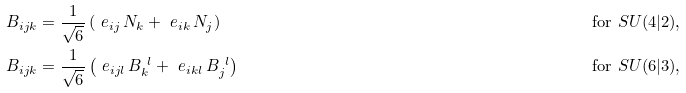<formula> <loc_0><loc_0><loc_500><loc_500>B _ { i j k } & = \frac { 1 } { \sqrt { 6 } } \left ( \ e _ { i j } \, N _ { k } + \ e _ { i k } \, N _ { j } \right ) & \text {for $SU(4|2)$,} \\ B _ { i j k } & = \frac { 1 } { \sqrt { 6 } } \left ( \ e _ { i j l } \, B _ { k } ^ { \ l } + \ e _ { i k l } \, B _ { j } ^ { \ l } \right ) & \text {for $SU(6|3)$,}</formula> 